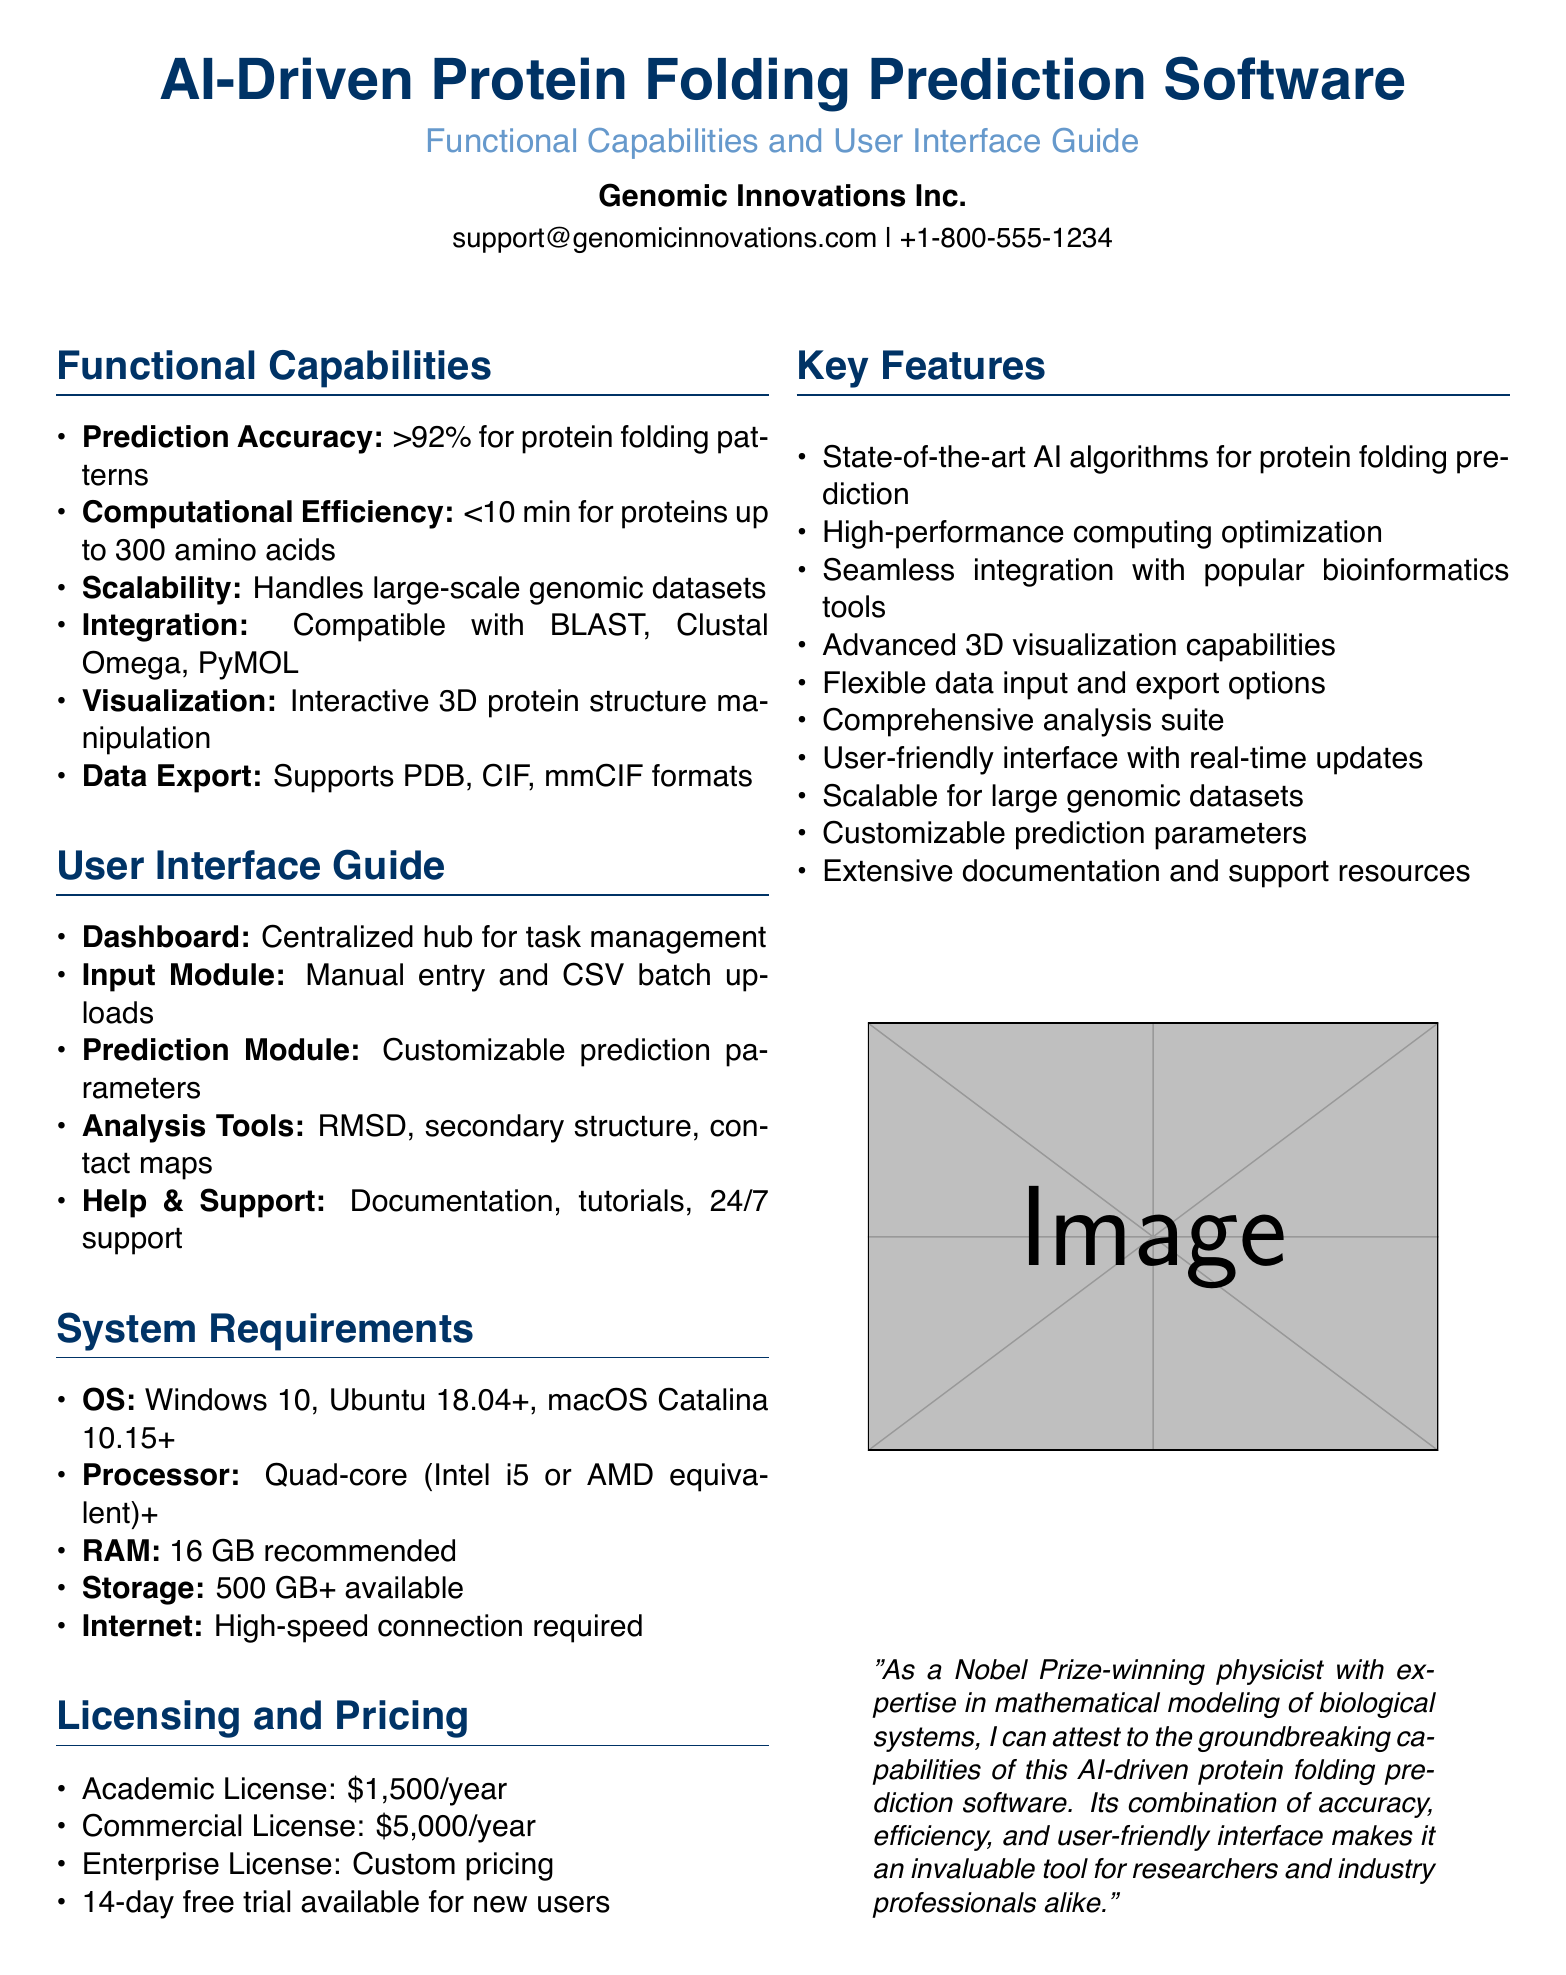what is the prediction accuracy? The prediction accuracy of the software is directly stated in the document as being over 92 percent.
Answer: >92% how long does it take to predict proteins? The document specifies that the computational efficiency is less than 10 minutes for proteins up to 300 amino acids.
Answer: <10 min which platforms is the software compatible with? The software's integration capabilities include several popular tools, which are listed in the section.
Answer: BLAST, Clustal Omega, PyMOL what is the recommended RAM for the software? The system requirements state that 16 GB of RAM is recommended for optimal performance of the software.
Answer: 16 GB what types of licenses are offered? The licensing section lists different types of licenses available, which include academic and commercial options.
Answer: Academic License, Commercial License, Enterprise License how many amino acids can the software handle for predictions? The document indicates the efficiency time reference specifically relates to a maximum length of 300 amino acids for protein predictions.
Answer: 300 amino acids what is the price of the commercial license? The document provides specific pricing information for the commercial license, clearly stating its cost.
Answer: $5,000/year does the software provide 3D visualization capabilities? The key features section highlights the advanced capabilities of the software, indicating its support for 3D visualization.
Answer: Yes what support options are available to users? The user interface guide mentions that help and support includes documentation, tutorials, and 24/7 assistance for users.
Answer: Documentation, tutorials, 24/7 support 